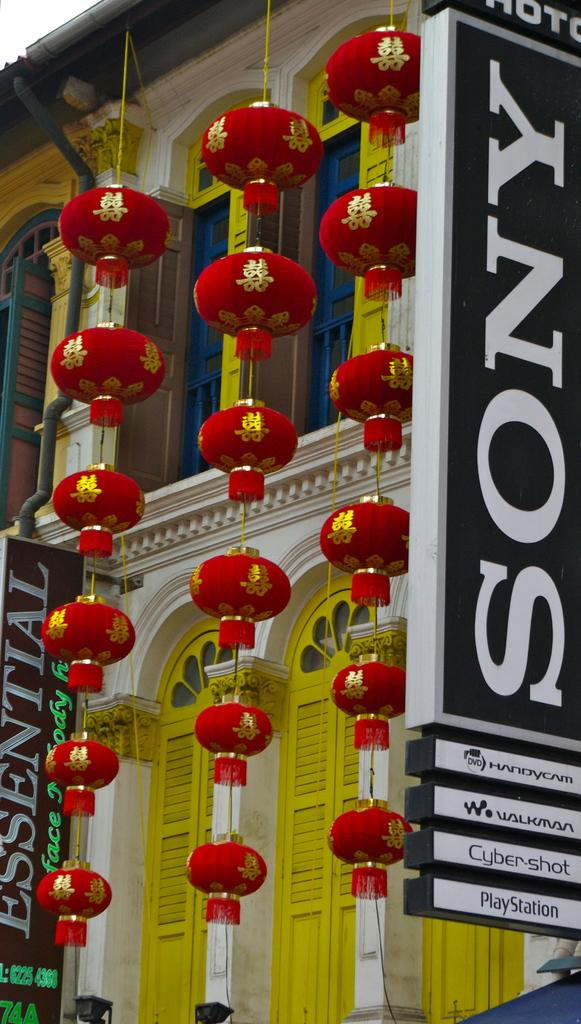What type of structure is visible in the image? There is a building in the image. What features can be seen on the building? The building has windows and doors. What else is present in the image besides the building? There are boards and decorative items in red and gold color in front of the building. What type of sweater is being worn by the brick in the image? There is no sweater or brick present in the image. 